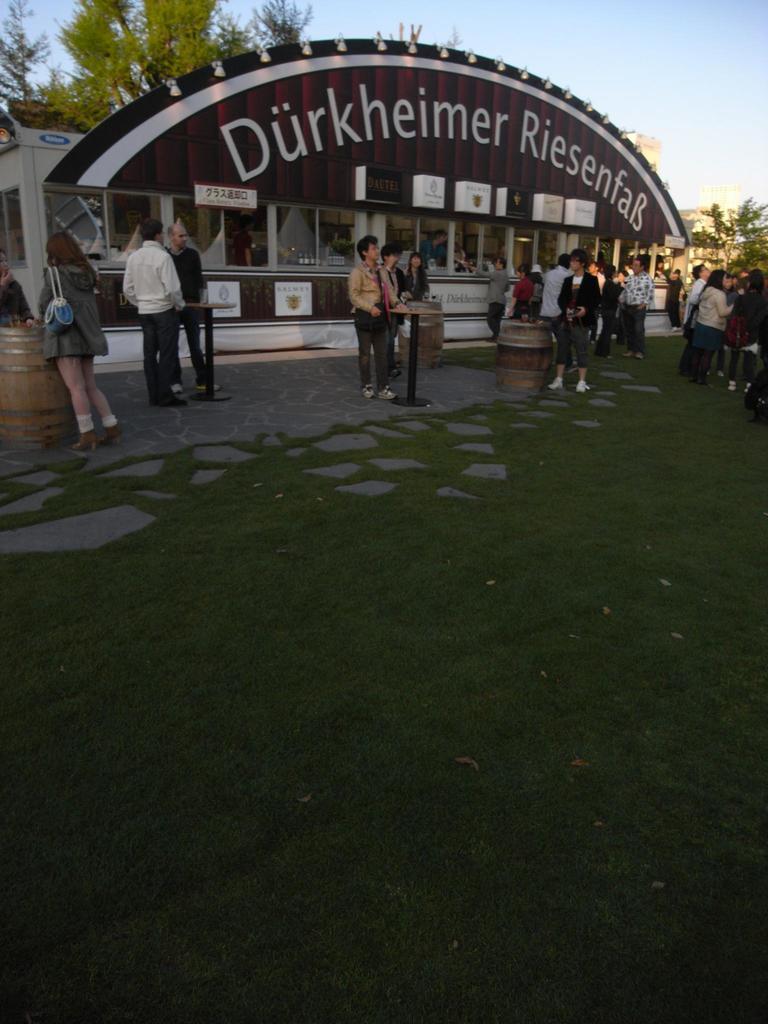Can you describe this image briefly? In the picture we can see a grass surface and some tiles on it and we can also see a path with some people and near to it, we can see some shop building with some glass windows to it and in the background we can see some trees and sky. 